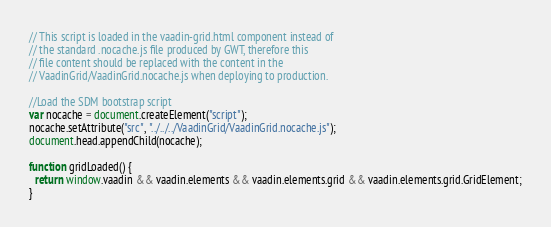<code> <loc_0><loc_0><loc_500><loc_500><_JavaScript_>// This script is loaded in the vaadin-grid.html component instead of
// the standard .nocache.js file produced by GWT, therefore this 
// file content should be replaced with the content in the 
// VaadinGrid/VaadinGrid.nocache.js when deploying to production.

//Load the SDM bootstrap script
var nocache = document.createElement("script");
nocache.setAttribute("src", "../../../VaadinGrid/VaadinGrid.nocache.js");
document.head.appendChild(nocache);

function gridLoaded() {
  return window.vaadin && vaadin.elements && vaadin.elements.grid && vaadin.elements.grid.GridElement;
}
</code> 